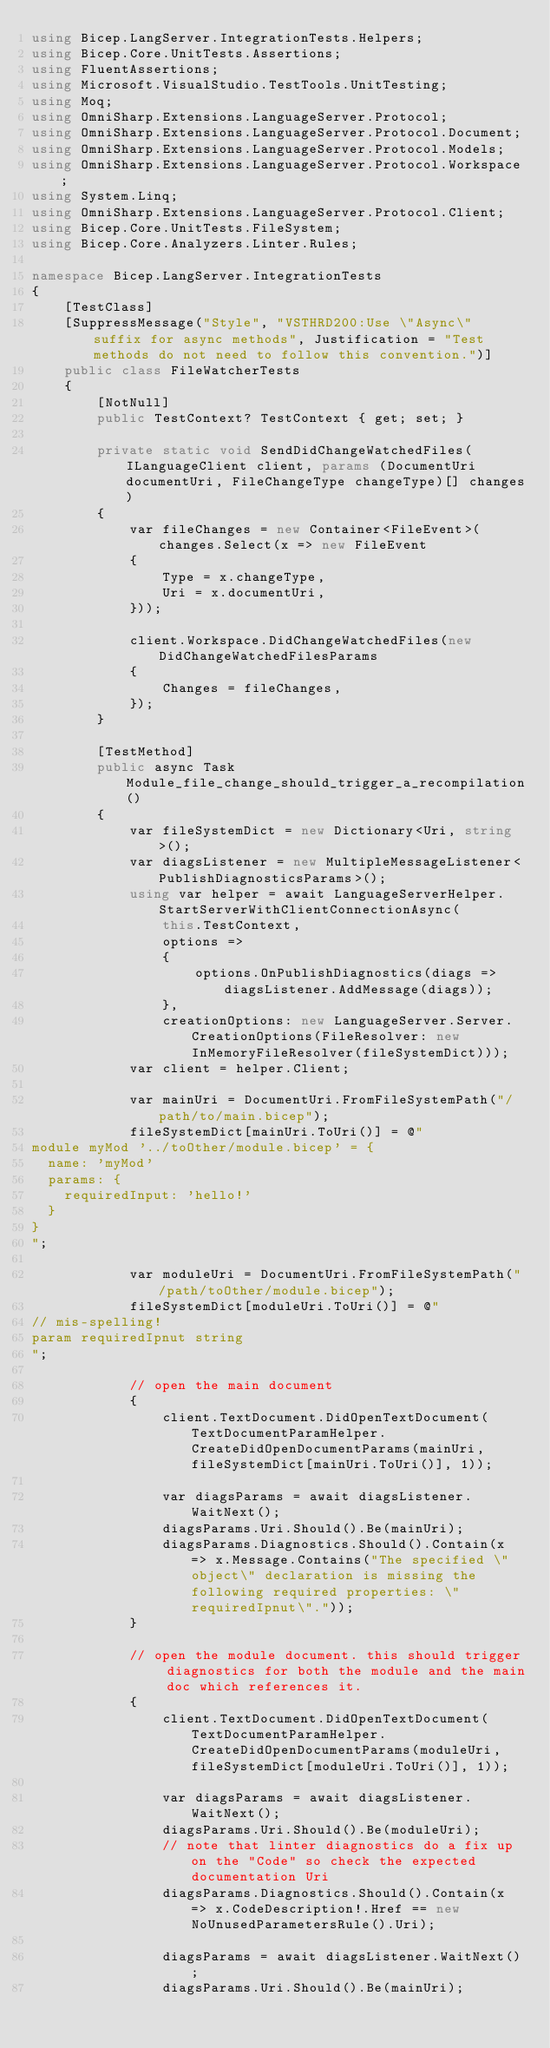<code> <loc_0><loc_0><loc_500><loc_500><_C#_>using Bicep.LangServer.IntegrationTests.Helpers;
using Bicep.Core.UnitTests.Assertions;
using FluentAssertions;
using Microsoft.VisualStudio.TestTools.UnitTesting;
using Moq;
using OmniSharp.Extensions.LanguageServer.Protocol;
using OmniSharp.Extensions.LanguageServer.Protocol.Document;
using OmniSharp.Extensions.LanguageServer.Protocol.Models;
using OmniSharp.Extensions.LanguageServer.Protocol.Workspace;
using System.Linq;
using OmniSharp.Extensions.LanguageServer.Protocol.Client;
using Bicep.Core.UnitTests.FileSystem;
using Bicep.Core.Analyzers.Linter.Rules;

namespace Bicep.LangServer.IntegrationTests
{
    [TestClass]
    [SuppressMessage("Style", "VSTHRD200:Use \"Async\" suffix for async methods", Justification = "Test methods do not need to follow this convention.")]
    public class FileWatcherTests
    {
        [NotNull]
        public TestContext? TestContext { get; set; }

        private static void SendDidChangeWatchedFiles(ILanguageClient client, params (DocumentUri documentUri, FileChangeType changeType)[] changes)
        {
            var fileChanges = new Container<FileEvent>(changes.Select(x => new FileEvent
            {
                Type = x.changeType,
                Uri = x.documentUri,
            }));

            client.Workspace.DidChangeWatchedFiles(new DidChangeWatchedFilesParams
            {
                Changes = fileChanges,
            });
        }

        [TestMethod]
        public async Task Module_file_change_should_trigger_a_recompilation()
        {
            var fileSystemDict = new Dictionary<Uri, string>();
            var diagsListener = new MultipleMessageListener<PublishDiagnosticsParams>();
            using var helper = await LanguageServerHelper.StartServerWithClientConnectionAsync(
                this.TestContext,
                options =>
                {
                    options.OnPublishDiagnostics(diags => diagsListener.AddMessage(diags));
                },
                creationOptions: new LanguageServer.Server.CreationOptions(FileResolver: new InMemoryFileResolver(fileSystemDict)));
            var client = helper.Client;

            var mainUri = DocumentUri.FromFileSystemPath("/path/to/main.bicep");
            fileSystemDict[mainUri.ToUri()] = @"
module myMod '../toOther/module.bicep' = {
  name: 'myMod'
  params: {
    requiredInput: 'hello!'
  }
}
";

            var moduleUri = DocumentUri.FromFileSystemPath("/path/toOther/module.bicep");
            fileSystemDict[moduleUri.ToUri()] = @"
// mis-spelling!
param requiredIpnut string
";

            // open the main document
            {
                client.TextDocument.DidOpenTextDocument(TextDocumentParamHelper.CreateDidOpenDocumentParams(mainUri, fileSystemDict[mainUri.ToUri()], 1));

                var diagsParams = await diagsListener.WaitNext();
                diagsParams.Uri.Should().Be(mainUri);
                diagsParams.Diagnostics.Should().Contain(x => x.Message.Contains("The specified \"object\" declaration is missing the following required properties: \"requiredIpnut\"."));
            }

            // open the module document. this should trigger diagnostics for both the module and the main doc which references it.
            {
                client.TextDocument.DidOpenTextDocument(TextDocumentParamHelper.CreateDidOpenDocumentParams(moduleUri, fileSystemDict[moduleUri.ToUri()], 1));

                var diagsParams = await diagsListener.WaitNext();
                diagsParams.Uri.Should().Be(moduleUri);
                // note that linter diagnostics do a fix up on the "Code" so check the expected documentation Uri
                diagsParams.Diagnostics.Should().Contain(x => x.CodeDescription!.Href == new NoUnusedParametersRule().Uri);

                diagsParams = await diagsListener.WaitNext();
                diagsParams.Uri.Should().Be(mainUri);</code> 